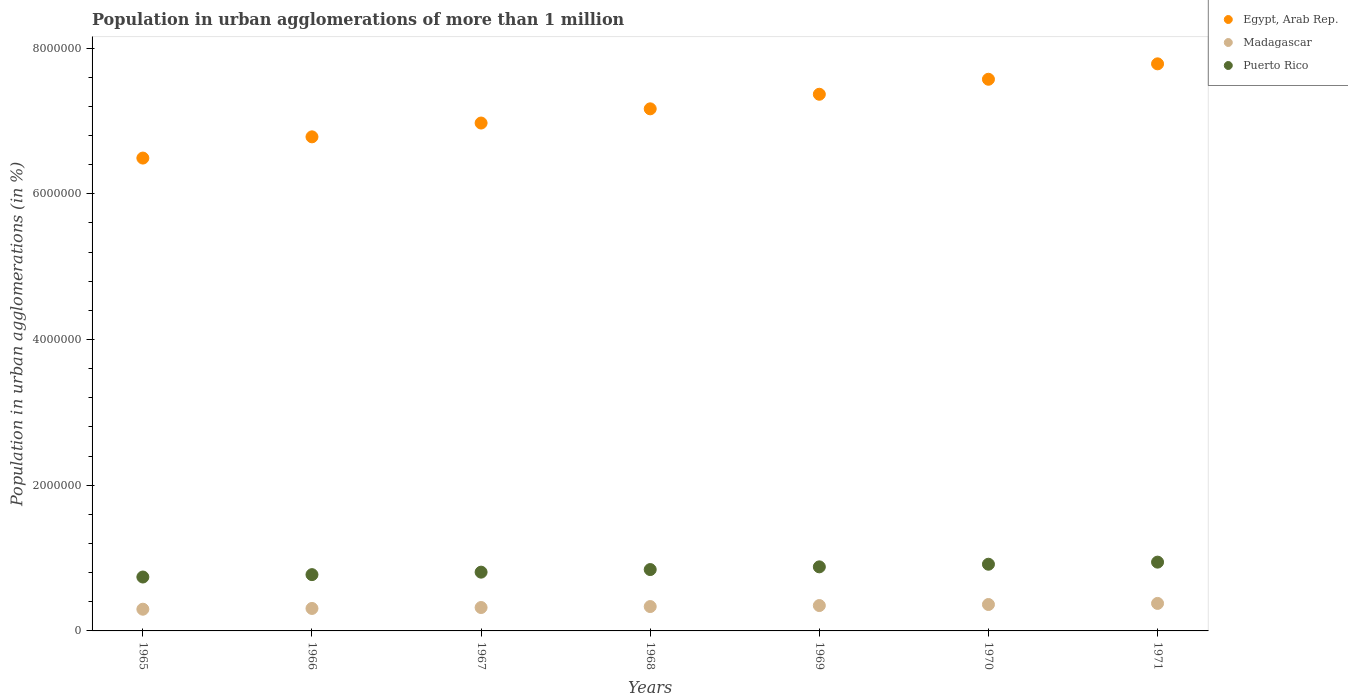How many different coloured dotlines are there?
Ensure brevity in your answer.  3. What is the population in urban agglomerations in Egypt, Arab Rep. in 1967?
Offer a terse response. 6.97e+06. Across all years, what is the maximum population in urban agglomerations in Puerto Rico?
Give a very brief answer. 9.44e+05. Across all years, what is the minimum population in urban agglomerations in Puerto Rico?
Make the answer very short. 7.40e+05. In which year was the population in urban agglomerations in Puerto Rico maximum?
Keep it short and to the point. 1971. In which year was the population in urban agglomerations in Egypt, Arab Rep. minimum?
Keep it short and to the point. 1965. What is the total population in urban agglomerations in Puerto Rico in the graph?
Your answer should be compact. 5.90e+06. What is the difference between the population in urban agglomerations in Egypt, Arab Rep. in 1966 and that in 1970?
Make the answer very short. -7.90e+05. What is the difference between the population in urban agglomerations in Puerto Rico in 1971 and the population in urban agglomerations in Egypt, Arab Rep. in 1967?
Offer a terse response. -6.03e+06. What is the average population in urban agglomerations in Puerto Rico per year?
Your response must be concise. 8.43e+05. In the year 1966, what is the difference between the population in urban agglomerations in Egypt, Arab Rep. and population in urban agglomerations in Puerto Rico?
Offer a very short reply. 6.01e+06. What is the ratio of the population in urban agglomerations in Egypt, Arab Rep. in 1965 to that in 1967?
Provide a short and direct response. 0.93. What is the difference between the highest and the second highest population in urban agglomerations in Madagascar?
Offer a terse response. 1.50e+04. What is the difference between the highest and the lowest population in urban agglomerations in Puerto Rico?
Keep it short and to the point. 2.04e+05. In how many years, is the population in urban agglomerations in Madagascar greater than the average population in urban agglomerations in Madagascar taken over all years?
Provide a short and direct response. 3. Is the sum of the population in urban agglomerations in Madagascar in 1968 and 1969 greater than the maximum population in urban agglomerations in Puerto Rico across all years?
Provide a succinct answer. No. Is it the case that in every year, the sum of the population in urban agglomerations in Egypt, Arab Rep. and population in urban agglomerations in Madagascar  is greater than the population in urban agglomerations in Puerto Rico?
Provide a short and direct response. Yes. Is the population in urban agglomerations in Egypt, Arab Rep. strictly greater than the population in urban agglomerations in Puerto Rico over the years?
Give a very brief answer. Yes. How many years are there in the graph?
Make the answer very short. 7. What is the difference between two consecutive major ticks on the Y-axis?
Offer a terse response. 2.00e+06. Are the values on the major ticks of Y-axis written in scientific E-notation?
Your answer should be very brief. No. Does the graph contain any zero values?
Provide a succinct answer. No. Does the graph contain grids?
Your response must be concise. No. Where does the legend appear in the graph?
Keep it short and to the point. Top right. How many legend labels are there?
Your answer should be very brief. 3. How are the legend labels stacked?
Offer a terse response. Vertical. What is the title of the graph?
Your answer should be compact. Population in urban agglomerations of more than 1 million. What is the label or title of the Y-axis?
Your answer should be very brief. Population in urban agglomerations (in %). What is the Population in urban agglomerations (in %) in Egypt, Arab Rep. in 1965?
Keep it short and to the point. 6.49e+06. What is the Population in urban agglomerations (in %) in Madagascar in 1965?
Ensure brevity in your answer.  2.98e+05. What is the Population in urban agglomerations (in %) in Puerto Rico in 1965?
Provide a short and direct response. 7.40e+05. What is the Population in urban agglomerations (in %) in Egypt, Arab Rep. in 1966?
Your answer should be compact. 6.78e+06. What is the Population in urban agglomerations (in %) of Madagascar in 1966?
Offer a terse response. 3.08e+05. What is the Population in urban agglomerations (in %) in Puerto Rico in 1966?
Offer a terse response. 7.72e+05. What is the Population in urban agglomerations (in %) in Egypt, Arab Rep. in 1967?
Keep it short and to the point. 6.97e+06. What is the Population in urban agglomerations (in %) of Madagascar in 1967?
Provide a short and direct response. 3.21e+05. What is the Population in urban agglomerations (in %) in Puerto Rico in 1967?
Keep it short and to the point. 8.07e+05. What is the Population in urban agglomerations (in %) in Egypt, Arab Rep. in 1968?
Provide a short and direct response. 7.17e+06. What is the Population in urban agglomerations (in %) in Madagascar in 1968?
Your answer should be very brief. 3.34e+05. What is the Population in urban agglomerations (in %) in Puerto Rico in 1968?
Provide a short and direct response. 8.42e+05. What is the Population in urban agglomerations (in %) of Egypt, Arab Rep. in 1969?
Provide a short and direct response. 7.37e+06. What is the Population in urban agglomerations (in %) in Madagascar in 1969?
Provide a succinct answer. 3.48e+05. What is the Population in urban agglomerations (in %) of Puerto Rico in 1969?
Your response must be concise. 8.79e+05. What is the Population in urban agglomerations (in %) of Egypt, Arab Rep. in 1970?
Your answer should be compact. 7.57e+06. What is the Population in urban agglomerations (in %) of Madagascar in 1970?
Provide a short and direct response. 3.63e+05. What is the Population in urban agglomerations (in %) of Puerto Rico in 1970?
Keep it short and to the point. 9.15e+05. What is the Population in urban agglomerations (in %) in Egypt, Arab Rep. in 1971?
Give a very brief answer. 7.78e+06. What is the Population in urban agglomerations (in %) of Madagascar in 1971?
Your response must be concise. 3.78e+05. What is the Population in urban agglomerations (in %) in Puerto Rico in 1971?
Ensure brevity in your answer.  9.44e+05. Across all years, what is the maximum Population in urban agglomerations (in %) of Egypt, Arab Rep.?
Provide a short and direct response. 7.78e+06. Across all years, what is the maximum Population in urban agglomerations (in %) in Madagascar?
Offer a very short reply. 3.78e+05. Across all years, what is the maximum Population in urban agglomerations (in %) of Puerto Rico?
Give a very brief answer. 9.44e+05. Across all years, what is the minimum Population in urban agglomerations (in %) in Egypt, Arab Rep.?
Keep it short and to the point. 6.49e+06. Across all years, what is the minimum Population in urban agglomerations (in %) of Madagascar?
Make the answer very short. 2.98e+05. Across all years, what is the minimum Population in urban agglomerations (in %) of Puerto Rico?
Offer a very short reply. 7.40e+05. What is the total Population in urban agglomerations (in %) of Egypt, Arab Rep. in the graph?
Offer a very short reply. 5.01e+07. What is the total Population in urban agglomerations (in %) of Madagascar in the graph?
Your answer should be very brief. 2.35e+06. What is the total Population in urban agglomerations (in %) in Puerto Rico in the graph?
Your answer should be compact. 5.90e+06. What is the difference between the Population in urban agglomerations (in %) of Egypt, Arab Rep. in 1965 and that in 1966?
Ensure brevity in your answer.  -2.91e+05. What is the difference between the Population in urban agglomerations (in %) of Madagascar in 1965 and that in 1966?
Offer a very short reply. -1.04e+04. What is the difference between the Population in urban agglomerations (in %) of Puerto Rico in 1965 and that in 1966?
Make the answer very short. -3.26e+04. What is the difference between the Population in urban agglomerations (in %) in Egypt, Arab Rep. in 1965 and that in 1967?
Offer a very short reply. -4.81e+05. What is the difference between the Population in urban agglomerations (in %) in Madagascar in 1965 and that in 1967?
Offer a terse response. -2.32e+04. What is the difference between the Population in urban agglomerations (in %) of Puerto Rico in 1965 and that in 1967?
Your answer should be very brief. -6.67e+04. What is the difference between the Population in urban agglomerations (in %) in Egypt, Arab Rep. in 1965 and that in 1968?
Provide a short and direct response. -6.76e+05. What is the difference between the Population in urban agglomerations (in %) of Madagascar in 1965 and that in 1968?
Keep it short and to the point. -3.65e+04. What is the difference between the Population in urban agglomerations (in %) of Puerto Rico in 1965 and that in 1968?
Give a very brief answer. -1.02e+05. What is the difference between the Population in urban agglomerations (in %) in Egypt, Arab Rep. in 1965 and that in 1969?
Make the answer very short. -8.76e+05. What is the difference between the Population in urban agglomerations (in %) of Madagascar in 1965 and that in 1969?
Ensure brevity in your answer.  -5.03e+04. What is the difference between the Population in urban agglomerations (in %) of Puerto Rico in 1965 and that in 1969?
Ensure brevity in your answer.  -1.39e+05. What is the difference between the Population in urban agglomerations (in %) in Egypt, Arab Rep. in 1965 and that in 1970?
Make the answer very short. -1.08e+06. What is the difference between the Population in urban agglomerations (in %) in Madagascar in 1965 and that in 1970?
Your answer should be very brief. -6.47e+04. What is the difference between the Population in urban agglomerations (in %) of Puerto Rico in 1965 and that in 1970?
Give a very brief answer. -1.75e+05. What is the difference between the Population in urban agglomerations (in %) of Egypt, Arab Rep. in 1965 and that in 1971?
Make the answer very short. -1.29e+06. What is the difference between the Population in urban agglomerations (in %) of Madagascar in 1965 and that in 1971?
Offer a terse response. -7.96e+04. What is the difference between the Population in urban agglomerations (in %) of Puerto Rico in 1965 and that in 1971?
Your response must be concise. -2.04e+05. What is the difference between the Population in urban agglomerations (in %) of Egypt, Arab Rep. in 1966 and that in 1967?
Provide a short and direct response. -1.89e+05. What is the difference between the Population in urban agglomerations (in %) in Madagascar in 1966 and that in 1967?
Ensure brevity in your answer.  -1.27e+04. What is the difference between the Population in urban agglomerations (in %) in Puerto Rico in 1966 and that in 1967?
Offer a very short reply. -3.41e+04. What is the difference between the Population in urban agglomerations (in %) of Egypt, Arab Rep. in 1966 and that in 1968?
Offer a very short reply. -3.84e+05. What is the difference between the Population in urban agglomerations (in %) of Madagascar in 1966 and that in 1968?
Ensure brevity in your answer.  -2.60e+04. What is the difference between the Population in urban agglomerations (in %) in Puerto Rico in 1966 and that in 1968?
Ensure brevity in your answer.  -6.97e+04. What is the difference between the Population in urban agglomerations (in %) of Egypt, Arab Rep. in 1966 and that in 1969?
Ensure brevity in your answer.  -5.84e+05. What is the difference between the Population in urban agglomerations (in %) in Madagascar in 1966 and that in 1969?
Keep it short and to the point. -3.98e+04. What is the difference between the Population in urban agglomerations (in %) of Puerto Rico in 1966 and that in 1969?
Keep it short and to the point. -1.07e+05. What is the difference between the Population in urban agglomerations (in %) of Egypt, Arab Rep. in 1966 and that in 1970?
Your answer should be very brief. -7.90e+05. What is the difference between the Population in urban agglomerations (in %) in Madagascar in 1966 and that in 1970?
Offer a terse response. -5.42e+04. What is the difference between the Population in urban agglomerations (in %) in Puerto Rico in 1966 and that in 1970?
Your answer should be compact. -1.43e+05. What is the difference between the Population in urban agglomerations (in %) of Egypt, Arab Rep. in 1966 and that in 1971?
Give a very brief answer. -1.00e+06. What is the difference between the Population in urban agglomerations (in %) of Madagascar in 1966 and that in 1971?
Provide a short and direct response. -6.92e+04. What is the difference between the Population in urban agglomerations (in %) in Puerto Rico in 1966 and that in 1971?
Keep it short and to the point. -1.72e+05. What is the difference between the Population in urban agglomerations (in %) of Egypt, Arab Rep. in 1967 and that in 1968?
Ensure brevity in your answer.  -1.95e+05. What is the difference between the Population in urban agglomerations (in %) in Madagascar in 1967 and that in 1968?
Your response must be concise. -1.33e+04. What is the difference between the Population in urban agglomerations (in %) of Puerto Rico in 1967 and that in 1968?
Provide a short and direct response. -3.56e+04. What is the difference between the Population in urban agglomerations (in %) in Egypt, Arab Rep. in 1967 and that in 1969?
Your response must be concise. -3.95e+05. What is the difference between the Population in urban agglomerations (in %) in Madagascar in 1967 and that in 1969?
Make the answer very short. -2.71e+04. What is the difference between the Population in urban agglomerations (in %) of Puerto Rico in 1967 and that in 1969?
Provide a short and direct response. -7.27e+04. What is the difference between the Population in urban agglomerations (in %) of Egypt, Arab Rep. in 1967 and that in 1970?
Provide a succinct answer. -6.01e+05. What is the difference between the Population in urban agglomerations (in %) of Madagascar in 1967 and that in 1970?
Provide a short and direct response. -4.15e+04. What is the difference between the Population in urban agglomerations (in %) in Puerto Rico in 1967 and that in 1970?
Make the answer very short. -1.09e+05. What is the difference between the Population in urban agglomerations (in %) in Egypt, Arab Rep. in 1967 and that in 1971?
Your answer should be compact. -8.12e+05. What is the difference between the Population in urban agglomerations (in %) in Madagascar in 1967 and that in 1971?
Your answer should be compact. -5.65e+04. What is the difference between the Population in urban agglomerations (in %) of Puerto Rico in 1967 and that in 1971?
Give a very brief answer. -1.38e+05. What is the difference between the Population in urban agglomerations (in %) of Egypt, Arab Rep. in 1968 and that in 1969?
Your answer should be compact. -2.00e+05. What is the difference between the Population in urban agglomerations (in %) in Madagascar in 1968 and that in 1969?
Keep it short and to the point. -1.38e+04. What is the difference between the Population in urban agglomerations (in %) of Puerto Rico in 1968 and that in 1969?
Offer a terse response. -3.71e+04. What is the difference between the Population in urban agglomerations (in %) in Egypt, Arab Rep. in 1968 and that in 1970?
Provide a succinct answer. -4.06e+05. What is the difference between the Population in urban agglomerations (in %) of Madagascar in 1968 and that in 1970?
Offer a very short reply. -2.82e+04. What is the difference between the Population in urban agglomerations (in %) in Puerto Rico in 1968 and that in 1970?
Provide a succinct answer. -7.31e+04. What is the difference between the Population in urban agglomerations (in %) in Egypt, Arab Rep. in 1968 and that in 1971?
Offer a terse response. -6.17e+05. What is the difference between the Population in urban agglomerations (in %) in Madagascar in 1968 and that in 1971?
Provide a short and direct response. -4.32e+04. What is the difference between the Population in urban agglomerations (in %) in Puerto Rico in 1968 and that in 1971?
Keep it short and to the point. -1.02e+05. What is the difference between the Population in urban agglomerations (in %) of Egypt, Arab Rep. in 1969 and that in 1970?
Ensure brevity in your answer.  -2.06e+05. What is the difference between the Population in urban agglomerations (in %) in Madagascar in 1969 and that in 1970?
Offer a terse response. -1.44e+04. What is the difference between the Population in urban agglomerations (in %) in Puerto Rico in 1969 and that in 1970?
Provide a succinct answer. -3.60e+04. What is the difference between the Population in urban agglomerations (in %) of Egypt, Arab Rep. in 1969 and that in 1971?
Provide a short and direct response. -4.18e+05. What is the difference between the Population in urban agglomerations (in %) of Madagascar in 1969 and that in 1971?
Give a very brief answer. -2.94e+04. What is the difference between the Population in urban agglomerations (in %) in Puerto Rico in 1969 and that in 1971?
Make the answer very short. -6.48e+04. What is the difference between the Population in urban agglomerations (in %) of Egypt, Arab Rep. in 1970 and that in 1971?
Offer a very short reply. -2.12e+05. What is the difference between the Population in urban agglomerations (in %) of Madagascar in 1970 and that in 1971?
Give a very brief answer. -1.50e+04. What is the difference between the Population in urban agglomerations (in %) of Puerto Rico in 1970 and that in 1971?
Ensure brevity in your answer.  -2.88e+04. What is the difference between the Population in urban agglomerations (in %) of Egypt, Arab Rep. in 1965 and the Population in urban agglomerations (in %) of Madagascar in 1966?
Offer a terse response. 6.18e+06. What is the difference between the Population in urban agglomerations (in %) in Egypt, Arab Rep. in 1965 and the Population in urban agglomerations (in %) in Puerto Rico in 1966?
Give a very brief answer. 5.72e+06. What is the difference between the Population in urban agglomerations (in %) of Madagascar in 1965 and the Population in urban agglomerations (in %) of Puerto Rico in 1966?
Your response must be concise. -4.75e+05. What is the difference between the Population in urban agglomerations (in %) in Egypt, Arab Rep. in 1965 and the Population in urban agglomerations (in %) in Madagascar in 1967?
Offer a very short reply. 6.17e+06. What is the difference between the Population in urban agglomerations (in %) in Egypt, Arab Rep. in 1965 and the Population in urban agglomerations (in %) in Puerto Rico in 1967?
Ensure brevity in your answer.  5.68e+06. What is the difference between the Population in urban agglomerations (in %) of Madagascar in 1965 and the Population in urban agglomerations (in %) of Puerto Rico in 1967?
Give a very brief answer. -5.09e+05. What is the difference between the Population in urban agglomerations (in %) of Egypt, Arab Rep. in 1965 and the Population in urban agglomerations (in %) of Madagascar in 1968?
Make the answer very short. 6.16e+06. What is the difference between the Population in urban agglomerations (in %) in Egypt, Arab Rep. in 1965 and the Population in urban agglomerations (in %) in Puerto Rico in 1968?
Offer a terse response. 5.65e+06. What is the difference between the Population in urban agglomerations (in %) of Madagascar in 1965 and the Population in urban agglomerations (in %) of Puerto Rico in 1968?
Provide a succinct answer. -5.44e+05. What is the difference between the Population in urban agglomerations (in %) in Egypt, Arab Rep. in 1965 and the Population in urban agglomerations (in %) in Madagascar in 1969?
Your answer should be compact. 6.14e+06. What is the difference between the Population in urban agglomerations (in %) of Egypt, Arab Rep. in 1965 and the Population in urban agglomerations (in %) of Puerto Rico in 1969?
Provide a short and direct response. 5.61e+06. What is the difference between the Population in urban agglomerations (in %) of Madagascar in 1965 and the Population in urban agglomerations (in %) of Puerto Rico in 1969?
Offer a terse response. -5.81e+05. What is the difference between the Population in urban agglomerations (in %) in Egypt, Arab Rep. in 1965 and the Population in urban agglomerations (in %) in Madagascar in 1970?
Offer a terse response. 6.13e+06. What is the difference between the Population in urban agglomerations (in %) of Egypt, Arab Rep. in 1965 and the Population in urban agglomerations (in %) of Puerto Rico in 1970?
Give a very brief answer. 5.57e+06. What is the difference between the Population in urban agglomerations (in %) of Madagascar in 1965 and the Population in urban agglomerations (in %) of Puerto Rico in 1970?
Provide a succinct answer. -6.17e+05. What is the difference between the Population in urban agglomerations (in %) in Egypt, Arab Rep. in 1965 and the Population in urban agglomerations (in %) in Madagascar in 1971?
Your answer should be compact. 6.11e+06. What is the difference between the Population in urban agglomerations (in %) of Egypt, Arab Rep. in 1965 and the Population in urban agglomerations (in %) of Puerto Rico in 1971?
Offer a very short reply. 5.55e+06. What is the difference between the Population in urban agglomerations (in %) of Madagascar in 1965 and the Population in urban agglomerations (in %) of Puerto Rico in 1971?
Ensure brevity in your answer.  -6.46e+05. What is the difference between the Population in urban agglomerations (in %) of Egypt, Arab Rep. in 1966 and the Population in urban agglomerations (in %) of Madagascar in 1967?
Your answer should be compact. 6.46e+06. What is the difference between the Population in urban agglomerations (in %) in Egypt, Arab Rep. in 1966 and the Population in urban agglomerations (in %) in Puerto Rico in 1967?
Your answer should be very brief. 5.97e+06. What is the difference between the Population in urban agglomerations (in %) in Madagascar in 1966 and the Population in urban agglomerations (in %) in Puerto Rico in 1967?
Provide a succinct answer. -4.98e+05. What is the difference between the Population in urban agglomerations (in %) of Egypt, Arab Rep. in 1966 and the Population in urban agglomerations (in %) of Madagascar in 1968?
Your answer should be very brief. 6.45e+06. What is the difference between the Population in urban agglomerations (in %) in Egypt, Arab Rep. in 1966 and the Population in urban agglomerations (in %) in Puerto Rico in 1968?
Offer a very short reply. 5.94e+06. What is the difference between the Population in urban agglomerations (in %) of Madagascar in 1966 and the Population in urban agglomerations (in %) of Puerto Rico in 1968?
Give a very brief answer. -5.34e+05. What is the difference between the Population in urban agglomerations (in %) in Egypt, Arab Rep. in 1966 and the Population in urban agglomerations (in %) in Madagascar in 1969?
Your response must be concise. 6.43e+06. What is the difference between the Population in urban agglomerations (in %) in Egypt, Arab Rep. in 1966 and the Population in urban agglomerations (in %) in Puerto Rico in 1969?
Offer a terse response. 5.90e+06. What is the difference between the Population in urban agglomerations (in %) of Madagascar in 1966 and the Population in urban agglomerations (in %) of Puerto Rico in 1969?
Provide a short and direct response. -5.71e+05. What is the difference between the Population in urban agglomerations (in %) of Egypt, Arab Rep. in 1966 and the Population in urban agglomerations (in %) of Madagascar in 1970?
Ensure brevity in your answer.  6.42e+06. What is the difference between the Population in urban agglomerations (in %) of Egypt, Arab Rep. in 1966 and the Population in urban agglomerations (in %) of Puerto Rico in 1970?
Your answer should be compact. 5.87e+06. What is the difference between the Population in urban agglomerations (in %) in Madagascar in 1966 and the Population in urban agglomerations (in %) in Puerto Rico in 1970?
Your response must be concise. -6.07e+05. What is the difference between the Population in urban agglomerations (in %) of Egypt, Arab Rep. in 1966 and the Population in urban agglomerations (in %) of Madagascar in 1971?
Your answer should be very brief. 6.40e+06. What is the difference between the Population in urban agglomerations (in %) of Egypt, Arab Rep. in 1966 and the Population in urban agglomerations (in %) of Puerto Rico in 1971?
Provide a short and direct response. 5.84e+06. What is the difference between the Population in urban agglomerations (in %) in Madagascar in 1966 and the Population in urban agglomerations (in %) in Puerto Rico in 1971?
Ensure brevity in your answer.  -6.36e+05. What is the difference between the Population in urban agglomerations (in %) in Egypt, Arab Rep. in 1967 and the Population in urban agglomerations (in %) in Madagascar in 1968?
Make the answer very short. 6.64e+06. What is the difference between the Population in urban agglomerations (in %) of Egypt, Arab Rep. in 1967 and the Population in urban agglomerations (in %) of Puerto Rico in 1968?
Give a very brief answer. 6.13e+06. What is the difference between the Population in urban agglomerations (in %) in Madagascar in 1967 and the Population in urban agglomerations (in %) in Puerto Rico in 1968?
Your answer should be compact. -5.21e+05. What is the difference between the Population in urban agglomerations (in %) of Egypt, Arab Rep. in 1967 and the Population in urban agglomerations (in %) of Madagascar in 1969?
Provide a short and direct response. 6.62e+06. What is the difference between the Population in urban agglomerations (in %) of Egypt, Arab Rep. in 1967 and the Population in urban agglomerations (in %) of Puerto Rico in 1969?
Your answer should be compact. 6.09e+06. What is the difference between the Population in urban agglomerations (in %) in Madagascar in 1967 and the Population in urban agglomerations (in %) in Puerto Rico in 1969?
Ensure brevity in your answer.  -5.58e+05. What is the difference between the Population in urban agglomerations (in %) in Egypt, Arab Rep. in 1967 and the Population in urban agglomerations (in %) in Madagascar in 1970?
Offer a terse response. 6.61e+06. What is the difference between the Population in urban agglomerations (in %) of Egypt, Arab Rep. in 1967 and the Population in urban agglomerations (in %) of Puerto Rico in 1970?
Your answer should be very brief. 6.06e+06. What is the difference between the Population in urban agglomerations (in %) in Madagascar in 1967 and the Population in urban agglomerations (in %) in Puerto Rico in 1970?
Keep it short and to the point. -5.94e+05. What is the difference between the Population in urban agglomerations (in %) in Egypt, Arab Rep. in 1967 and the Population in urban agglomerations (in %) in Madagascar in 1971?
Offer a very short reply. 6.59e+06. What is the difference between the Population in urban agglomerations (in %) of Egypt, Arab Rep. in 1967 and the Population in urban agglomerations (in %) of Puerto Rico in 1971?
Ensure brevity in your answer.  6.03e+06. What is the difference between the Population in urban agglomerations (in %) in Madagascar in 1967 and the Population in urban agglomerations (in %) in Puerto Rico in 1971?
Provide a succinct answer. -6.23e+05. What is the difference between the Population in urban agglomerations (in %) of Egypt, Arab Rep. in 1968 and the Population in urban agglomerations (in %) of Madagascar in 1969?
Provide a succinct answer. 6.82e+06. What is the difference between the Population in urban agglomerations (in %) in Egypt, Arab Rep. in 1968 and the Population in urban agglomerations (in %) in Puerto Rico in 1969?
Your response must be concise. 6.29e+06. What is the difference between the Population in urban agglomerations (in %) of Madagascar in 1968 and the Population in urban agglomerations (in %) of Puerto Rico in 1969?
Provide a succinct answer. -5.45e+05. What is the difference between the Population in urban agglomerations (in %) of Egypt, Arab Rep. in 1968 and the Population in urban agglomerations (in %) of Madagascar in 1970?
Make the answer very short. 6.80e+06. What is the difference between the Population in urban agglomerations (in %) in Egypt, Arab Rep. in 1968 and the Population in urban agglomerations (in %) in Puerto Rico in 1970?
Your answer should be very brief. 6.25e+06. What is the difference between the Population in urban agglomerations (in %) of Madagascar in 1968 and the Population in urban agglomerations (in %) of Puerto Rico in 1970?
Keep it short and to the point. -5.81e+05. What is the difference between the Population in urban agglomerations (in %) in Egypt, Arab Rep. in 1968 and the Population in urban agglomerations (in %) in Madagascar in 1971?
Your answer should be very brief. 6.79e+06. What is the difference between the Population in urban agglomerations (in %) of Egypt, Arab Rep. in 1968 and the Population in urban agglomerations (in %) of Puerto Rico in 1971?
Provide a succinct answer. 6.22e+06. What is the difference between the Population in urban agglomerations (in %) in Madagascar in 1968 and the Population in urban agglomerations (in %) in Puerto Rico in 1971?
Make the answer very short. -6.10e+05. What is the difference between the Population in urban agglomerations (in %) of Egypt, Arab Rep. in 1969 and the Population in urban agglomerations (in %) of Madagascar in 1970?
Keep it short and to the point. 7.00e+06. What is the difference between the Population in urban agglomerations (in %) of Egypt, Arab Rep. in 1969 and the Population in urban agglomerations (in %) of Puerto Rico in 1970?
Keep it short and to the point. 6.45e+06. What is the difference between the Population in urban agglomerations (in %) of Madagascar in 1969 and the Population in urban agglomerations (in %) of Puerto Rico in 1970?
Provide a succinct answer. -5.67e+05. What is the difference between the Population in urban agglomerations (in %) in Egypt, Arab Rep. in 1969 and the Population in urban agglomerations (in %) in Madagascar in 1971?
Offer a terse response. 6.99e+06. What is the difference between the Population in urban agglomerations (in %) in Egypt, Arab Rep. in 1969 and the Population in urban agglomerations (in %) in Puerto Rico in 1971?
Your answer should be compact. 6.42e+06. What is the difference between the Population in urban agglomerations (in %) of Madagascar in 1969 and the Population in urban agglomerations (in %) of Puerto Rico in 1971?
Provide a short and direct response. -5.96e+05. What is the difference between the Population in urban agglomerations (in %) in Egypt, Arab Rep. in 1970 and the Population in urban agglomerations (in %) in Madagascar in 1971?
Ensure brevity in your answer.  7.19e+06. What is the difference between the Population in urban agglomerations (in %) in Egypt, Arab Rep. in 1970 and the Population in urban agglomerations (in %) in Puerto Rico in 1971?
Your response must be concise. 6.63e+06. What is the difference between the Population in urban agglomerations (in %) of Madagascar in 1970 and the Population in urban agglomerations (in %) of Puerto Rico in 1971?
Give a very brief answer. -5.81e+05. What is the average Population in urban agglomerations (in %) in Egypt, Arab Rep. per year?
Keep it short and to the point. 7.16e+06. What is the average Population in urban agglomerations (in %) of Madagascar per year?
Ensure brevity in your answer.  3.36e+05. What is the average Population in urban agglomerations (in %) of Puerto Rico per year?
Offer a terse response. 8.43e+05. In the year 1965, what is the difference between the Population in urban agglomerations (in %) in Egypt, Arab Rep. and Population in urban agglomerations (in %) in Madagascar?
Offer a terse response. 6.19e+06. In the year 1965, what is the difference between the Population in urban agglomerations (in %) of Egypt, Arab Rep. and Population in urban agglomerations (in %) of Puerto Rico?
Provide a short and direct response. 5.75e+06. In the year 1965, what is the difference between the Population in urban agglomerations (in %) of Madagascar and Population in urban agglomerations (in %) of Puerto Rico?
Provide a succinct answer. -4.42e+05. In the year 1966, what is the difference between the Population in urban agglomerations (in %) of Egypt, Arab Rep. and Population in urban agglomerations (in %) of Madagascar?
Your response must be concise. 6.47e+06. In the year 1966, what is the difference between the Population in urban agglomerations (in %) in Egypt, Arab Rep. and Population in urban agglomerations (in %) in Puerto Rico?
Keep it short and to the point. 6.01e+06. In the year 1966, what is the difference between the Population in urban agglomerations (in %) of Madagascar and Population in urban agglomerations (in %) of Puerto Rico?
Ensure brevity in your answer.  -4.64e+05. In the year 1967, what is the difference between the Population in urban agglomerations (in %) in Egypt, Arab Rep. and Population in urban agglomerations (in %) in Madagascar?
Give a very brief answer. 6.65e+06. In the year 1967, what is the difference between the Population in urban agglomerations (in %) of Egypt, Arab Rep. and Population in urban agglomerations (in %) of Puerto Rico?
Your answer should be compact. 6.16e+06. In the year 1967, what is the difference between the Population in urban agglomerations (in %) in Madagascar and Population in urban agglomerations (in %) in Puerto Rico?
Your answer should be very brief. -4.85e+05. In the year 1968, what is the difference between the Population in urban agglomerations (in %) in Egypt, Arab Rep. and Population in urban agglomerations (in %) in Madagascar?
Make the answer very short. 6.83e+06. In the year 1968, what is the difference between the Population in urban agglomerations (in %) in Egypt, Arab Rep. and Population in urban agglomerations (in %) in Puerto Rico?
Provide a succinct answer. 6.32e+06. In the year 1968, what is the difference between the Population in urban agglomerations (in %) of Madagascar and Population in urban agglomerations (in %) of Puerto Rico?
Offer a very short reply. -5.08e+05. In the year 1969, what is the difference between the Population in urban agglomerations (in %) in Egypt, Arab Rep. and Population in urban agglomerations (in %) in Madagascar?
Ensure brevity in your answer.  7.02e+06. In the year 1969, what is the difference between the Population in urban agglomerations (in %) in Egypt, Arab Rep. and Population in urban agglomerations (in %) in Puerto Rico?
Give a very brief answer. 6.49e+06. In the year 1969, what is the difference between the Population in urban agglomerations (in %) of Madagascar and Population in urban agglomerations (in %) of Puerto Rico?
Your answer should be compact. -5.31e+05. In the year 1970, what is the difference between the Population in urban agglomerations (in %) in Egypt, Arab Rep. and Population in urban agglomerations (in %) in Madagascar?
Make the answer very short. 7.21e+06. In the year 1970, what is the difference between the Population in urban agglomerations (in %) of Egypt, Arab Rep. and Population in urban agglomerations (in %) of Puerto Rico?
Keep it short and to the point. 6.66e+06. In the year 1970, what is the difference between the Population in urban agglomerations (in %) in Madagascar and Population in urban agglomerations (in %) in Puerto Rico?
Give a very brief answer. -5.53e+05. In the year 1971, what is the difference between the Population in urban agglomerations (in %) of Egypt, Arab Rep. and Population in urban agglomerations (in %) of Madagascar?
Provide a short and direct response. 7.41e+06. In the year 1971, what is the difference between the Population in urban agglomerations (in %) of Egypt, Arab Rep. and Population in urban agglomerations (in %) of Puerto Rico?
Your answer should be compact. 6.84e+06. In the year 1971, what is the difference between the Population in urban agglomerations (in %) of Madagascar and Population in urban agglomerations (in %) of Puerto Rico?
Offer a terse response. -5.66e+05. What is the ratio of the Population in urban agglomerations (in %) in Egypt, Arab Rep. in 1965 to that in 1966?
Keep it short and to the point. 0.96. What is the ratio of the Population in urban agglomerations (in %) of Madagascar in 1965 to that in 1966?
Your response must be concise. 0.97. What is the ratio of the Population in urban agglomerations (in %) in Puerto Rico in 1965 to that in 1966?
Give a very brief answer. 0.96. What is the ratio of the Population in urban agglomerations (in %) in Madagascar in 1965 to that in 1967?
Offer a terse response. 0.93. What is the ratio of the Population in urban agglomerations (in %) of Puerto Rico in 1965 to that in 1967?
Make the answer very short. 0.92. What is the ratio of the Population in urban agglomerations (in %) of Egypt, Arab Rep. in 1965 to that in 1968?
Offer a very short reply. 0.91. What is the ratio of the Population in urban agglomerations (in %) in Madagascar in 1965 to that in 1968?
Your answer should be very brief. 0.89. What is the ratio of the Population in urban agglomerations (in %) of Puerto Rico in 1965 to that in 1968?
Keep it short and to the point. 0.88. What is the ratio of the Population in urban agglomerations (in %) of Egypt, Arab Rep. in 1965 to that in 1969?
Provide a short and direct response. 0.88. What is the ratio of the Population in urban agglomerations (in %) of Madagascar in 1965 to that in 1969?
Your answer should be very brief. 0.86. What is the ratio of the Population in urban agglomerations (in %) of Puerto Rico in 1965 to that in 1969?
Provide a succinct answer. 0.84. What is the ratio of the Population in urban agglomerations (in %) in Madagascar in 1965 to that in 1970?
Provide a succinct answer. 0.82. What is the ratio of the Population in urban agglomerations (in %) of Puerto Rico in 1965 to that in 1970?
Keep it short and to the point. 0.81. What is the ratio of the Population in urban agglomerations (in %) of Egypt, Arab Rep. in 1965 to that in 1971?
Give a very brief answer. 0.83. What is the ratio of the Population in urban agglomerations (in %) of Madagascar in 1965 to that in 1971?
Ensure brevity in your answer.  0.79. What is the ratio of the Population in urban agglomerations (in %) in Puerto Rico in 1965 to that in 1971?
Offer a terse response. 0.78. What is the ratio of the Population in urban agglomerations (in %) in Egypt, Arab Rep. in 1966 to that in 1967?
Give a very brief answer. 0.97. What is the ratio of the Population in urban agglomerations (in %) of Madagascar in 1966 to that in 1967?
Your answer should be very brief. 0.96. What is the ratio of the Population in urban agglomerations (in %) in Puerto Rico in 1966 to that in 1967?
Provide a short and direct response. 0.96. What is the ratio of the Population in urban agglomerations (in %) of Egypt, Arab Rep. in 1966 to that in 1968?
Your answer should be very brief. 0.95. What is the ratio of the Population in urban agglomerations (in %) in Madagascar in 1966 to that in 1968?
Your answer should be compact. 0.92. What is the ratio of the Population in urban agglomerations (in %) in Puerto Rico in 1966 to that in 1968?
Your response must be concise. 0.92. What is the ratio of the Population in urban agglomerations (in %) in Egypt, Arab Rep. in 1966 to that in 1969?
Provide a short and direct response. 0.92. What is the ratio of the Population in urban agglomerations (in %) of Madagascar in 1966 to that in 1969?
Provide a short and direct response. 0.89. What is the ratio of the Population in urban agglomerations (in %) of Puerto Rico in 1966 to that in 1969?
Make the answer very short. 0.88. What is the ratio of the Population in urban agglomerations (in %) of Egypt, Arab Rep. in 1966 to that in 1970?
Your answer should be compact. 0.9. What is the ratio of the Population in urban agglomerations (in %) of Madagascar in 1966 to that in 1970?
Offer a very short reply. 0.85. What is the ratio of the Population in urban agglomerations (in %) in Puerto Rico in 1966 to that in 1970?
Provide a succinct answer. 0.84. What is the ratio of the Population in urban agglomerations (in %) of Egypt, Arab Rep. in 1966 to that in 1971?
Your response must be concise. 0.87. What is the ratio of the Population in urban agglomerations (in %) in Madagascar in 1966 to that in 1971?
Your response must be concise. 0.82. What is the ratio of the Population in urban agglomerations (in %) of Puerto Rico in 1966 to that in 1971?
Your response must be concise. 0.82. What is the ratio of the Population in urban agglomerations (in %) of Egypt, Arab Rep. in 1967 to that in 1968?
Your answer should be compact. 0.97. What is the ratio of the Population in urban agglomerations (in %) of Madagascar in 1967 to that in 1968?
Keep it short and to the point. 0.96. What is the ratio of the Population in urban agglomerations (in %) of Puerto Rico in 1967 to that in 1968?
Provide a succinct answer. 0.96. What is the ratio of the Population in urban agglomerations (in %) of Egypt, Arab Rep. in 1967 to that in 1969?
Your answer should be very brief. 0.95. What is the ratio of the Population in urban agglomerations (in %) in Madagascar in 1967 to that in 1969?
Offer a terse response. 0.92. What is the ratio of the Population in urban agglomerations (in %) in Puerto Rico in 1967 to that in 1969?
Your answer should be very brief. 0.92. What is the ratio of the Population in urban agglomerations (in %) in Egypt, Arab Rep. in 1967 to that in 1970?
Offer a terse response. 0.92. What is the ratio of the Population in urban agglomerations (in %) in Madagascar in 1967 to that in 1970?
Your answer should be very brief. 0.89. What is the ratio of the Population in urban agglomerations (in %) of Puerto Rico in 1967 to that in 1970?
Your answer should be compact. 0.88. What is the ratio of the Population in urban agglomerations (in %) in Egypt, Arab Rep. in 1967 to that in 1971?
Provide a succinct answer. 0.9. What is the ratio of the Population in urban agglomerations (in %) in Madagascar in 1967 to that in 1971?
Keep it short and to the point. 0.85. What is the ratio of the Population in urban agglomerations (in %) in Puerto Rico in 1967 to that in 1971?
Offer a very short reply. 0.85. What is the ratio of the Population in urban agglomerations (in %) of Egypt, Arab Rep. in 1968 to that in 1969?
Make the answer very short. 0.97. What is the ratio of the Population in urban agglomerations (in %) of Madagascar in 1968 to that in 1969?
Keep it short and to the point. 0.96. What is the ratio of the Population in urban agglomerations (in %) of Puerto Rico in 1968 to that in 1969?
Keep it short and to the point. 0.96. What is the ratio of the Population in urban agglomerations (in %) of Egypt, Arab Rep. in 1968 to that in 1970?
Keep it short and to the point. 0.95. What is the ratio of the Population in urban agglomerations (in %) in Madagascar in 1968 to that in 1970?
Give a very brief answer. 0.92. What is the ratio of the Population in urban agglomerations (in %) in Puerto Rico in 1968 to that in 1970?
Your answer should be very brief. 0.92. What is the ratio of the Population in urban agglomerations (in %) of Egypt, Arab Rep. in 1968 to that in 1971?
Give a very brief answer. 0.92. What is the ratio of the Population in urban agglomerations (in %) of Madagascar in 1968 to that in 1971?
Provide a short and direct response. 0.89. What is the ratio of the Population in urban agglomerations (in %) of Puerto Rico in 1968 to that in 1971?
Provide a short and direct response. 0.89. What is the ratio of the Population in urban agglomerations (in %) of Egypt, Arab Rep. in 1969 to that in 1970?
Your answer should be very brief. 0.97. What is the ratio of the Population in urban agglomerations (in %) of Madagascar in 1969 to that in 1970?
Offer a very short reply. 0.96. What is the ratio of the Population in urban agglomerations (in %) in Puerto Rico in 1969 to that in 1970?
Offer a very short reply. 0.96. What is the ratio of the Population in urban agglomerations (in %) in Egypt, Arab Rep. in 1969 to that in 1971?
Your response must be concise. 0.95. What is the ratio of the Population in urban agglomerations (in %) in Madagascar in 1969 to that in 1971?
Make the answer very short. 0.92. What is the ratio of the Population in urban agglomerations (in %) in Puerto Rico in 1969 to that in 1971?
Offer a terse response. 0.93. What is the ratio of the Population in urban agglomerations (in %) of Egypt, Arab Rep. in 1970 to that in 1971?
Your answer should be compact. 0.97. What is the ratio of the Population in urban agglomerations (in %) of Madagascar in 1970 to that in 1971?
Offer a terse response. 0.96. What is the ratio of the Population in urban agglomerations (in %) of Puerto Rico in 1970 to that in 1971?
Your response must be concise. 0.97. What is the difference between the highest and the second highest Population in urban agglomerations (in %) of Egypt, Arab Rep.?
Ensure brevity in your answer.  2.12e+05. What is the difference between the highest and the second highest Population in urban agglomerations (in %) in Madagascar?
Your answer should be compact. 1.50e+04. What is the difference between the highest and the second highest Population in urban agglomerations (in %) in Puerto Rico?
Offer a very short reply. 2.88e+04. What is the difference between the highest and the lowest Population in urban agglomerations (in %) in Egypt, Arab Rep.?
Make the answer very short. 1.29e+06. What is the difference between the highest and the lowest Population in urban agglomerations (in %) in Madagascar?
Your answer should be compact. 7.96e+04. What is the difference between the highest and the lowest Population in urban agglomerations (in %) in Puerto Rico?
Ensure brevity in your answer.  2.04e+05. 